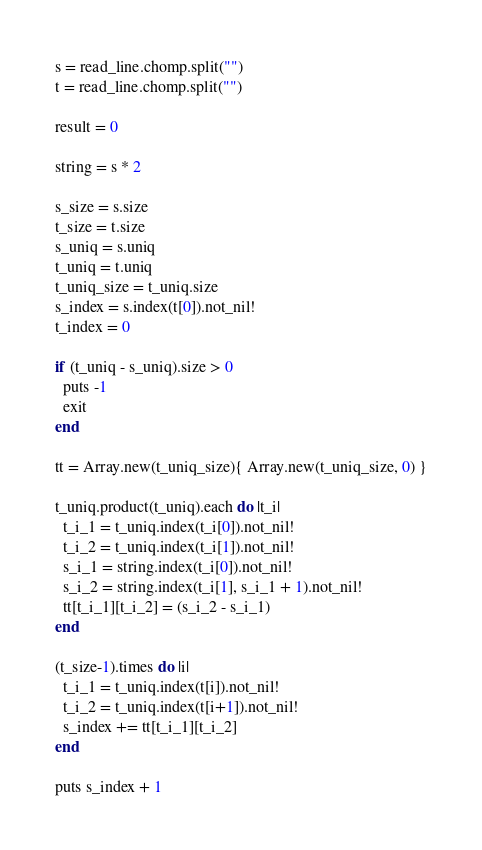<code> <loc_0><loc_0><loc_500><loc_500><_Crystal_>s = read_line.chomp.split("")
t = read_line.chomp.split("")

result = 0

string = s * 2

s_size = s.size
t_size = t.size
s_uniq = s.uniq
t_uniq = t.uniq
t_uniq_size = t_uniq.size
s_index = s.index(t[0]).not_nil!
t_index = 0

if (t_uniq - s_uniq).size > 0
  puts -1
  exit
end

tt = Array.new(t_uniq_size){ Array.new(t_uniq_size, 0) }

t_uniq.product(t_uniq).each do |t_i|
  t_i_1 = t_uniq.index(t_i[0]).not_nil!
  t_i_2 = t_uniq.index(t_i[1]).not_nil!
  s_i_1 = string.index(t_i[0]).not_nil!
  s_i_2 = string.index(t_i[1], s_i_1 + 1).not_nil!
  tt[t_i_1][t_i_2] = (s_i_2 - s_i_1)
end

(t_size-1).times do |i|
  t_i_1 = t_uniq.index(t[i]).not_nil!
  t_i_2 = t_uniq.index(t[i+1]).not_nil!
  s_index += tt[t_i_1][t_i_2]
end

puts s_index + 1
</code> 